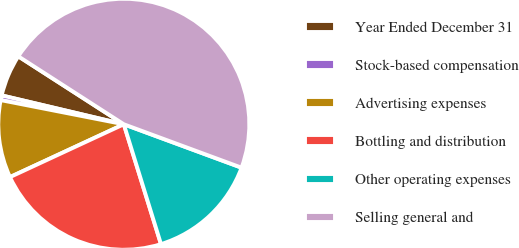Convert chart. <chart><loc_0><loc_0><loc_500><loc_500><pie_chart><fcel>Year Ended December 31<fcel>Stock-based compensation<fcel>Advertising expenses<fcel>Bottling and distribution<fcel>Other operating expenses<fcel>Selling general and<nl><fcel>5.41%<fcel>0.61%<fcel>10.0%<fcel>22.87%<fcel>14.59%<fcel>46.52%<nl></chart> 